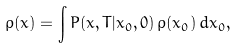<formula> <loc_0><loc_0><loc_500><loc_500>\rho ( x ) = \int P ( x , T | x _ { 0 } , 0 ) \, \rho ( x _ { 0 } ) \, d x _ { 0 } ,</formula> 